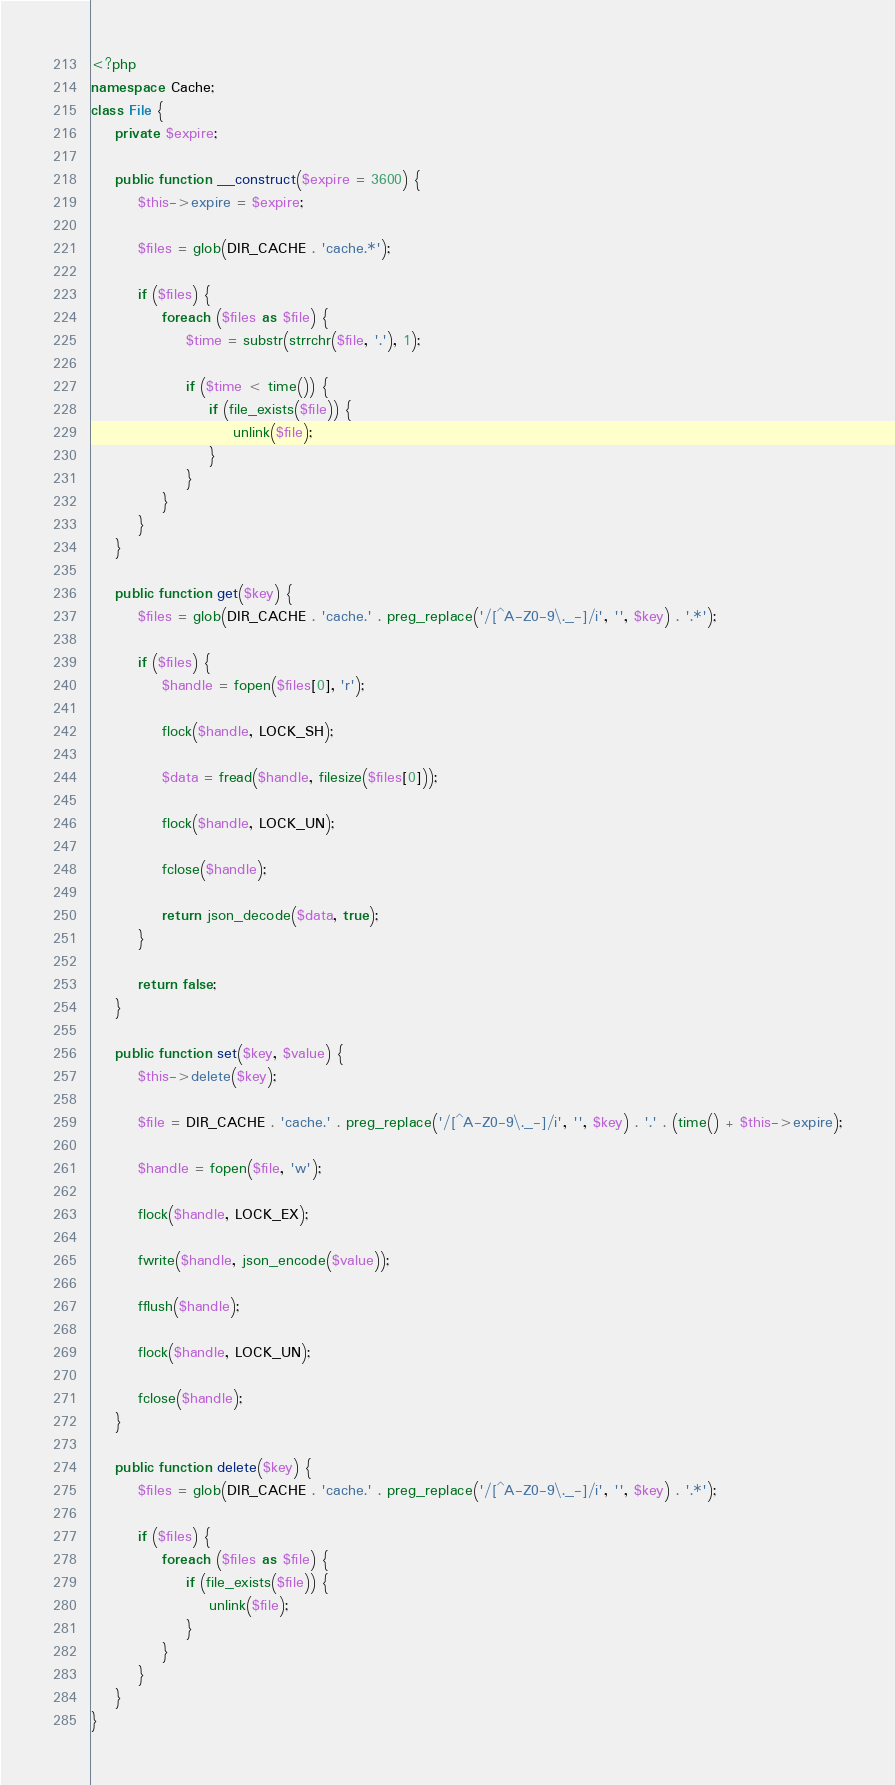Convert code to text. <code><loc_0><loc_0><loc_500><loc_500><_PHP_><?php
namespace Cache;
class File {
	private $expire;

	public function __construct($expire = 3600) {
		$this->expire = $expire;

		$files = glob(DIR_CACHE . 'cache.*');

		if ($files) {
			foreach ($files as $file) {
				$time = substr(strrchr($file, '.'), 1);

				if ($time < time()) {
					if (file_exists($file)) {
						unlink($file);
					}
				}
			}
		}
	}

	public function get($key) {
		$files = glob(DIR_CACHE . 'cache.' . preg_replace('/[^A-Z0-9\._-]/i', '', $key) . '.*');

		if ($files) {
			$handle = fopen($files[0], 'r');

			flock($handle, LOCK_SH);

			$data = fread($handle, filesize($files[0]));

			flock($handle, LOCK_UN);

			fclose($handle);

			return json_decode($data, true);
		}

		return false;
	}

	public function set($key, $value) {
		$this->delete($key);

		$file = DIR_CACHE . 'cache.' . preg_replace('/[^A-Z0-9\._-]/i', '', $key) . '.' . (time() + $this->expire);

		$handle = fopen($file, 'w');

		flock($handle, LOCK_EX);

		fwrite($handle, json_encode($value));

		fflush($handle);

		flock($handle, LOCK_UN);

		fclose($handle);
	}

	public function delete($key) {
		$files = glob(DIR_CACHE . 'cache.' . preg_replace('/[^A-Z0-9\._-]/i', '', $key) . '.*');

		if ($files) {
			foreach ($files as $file) {
				if (file_exists($file)) {
					unlink($file);
				}
			}
		}
	}
}</code> 